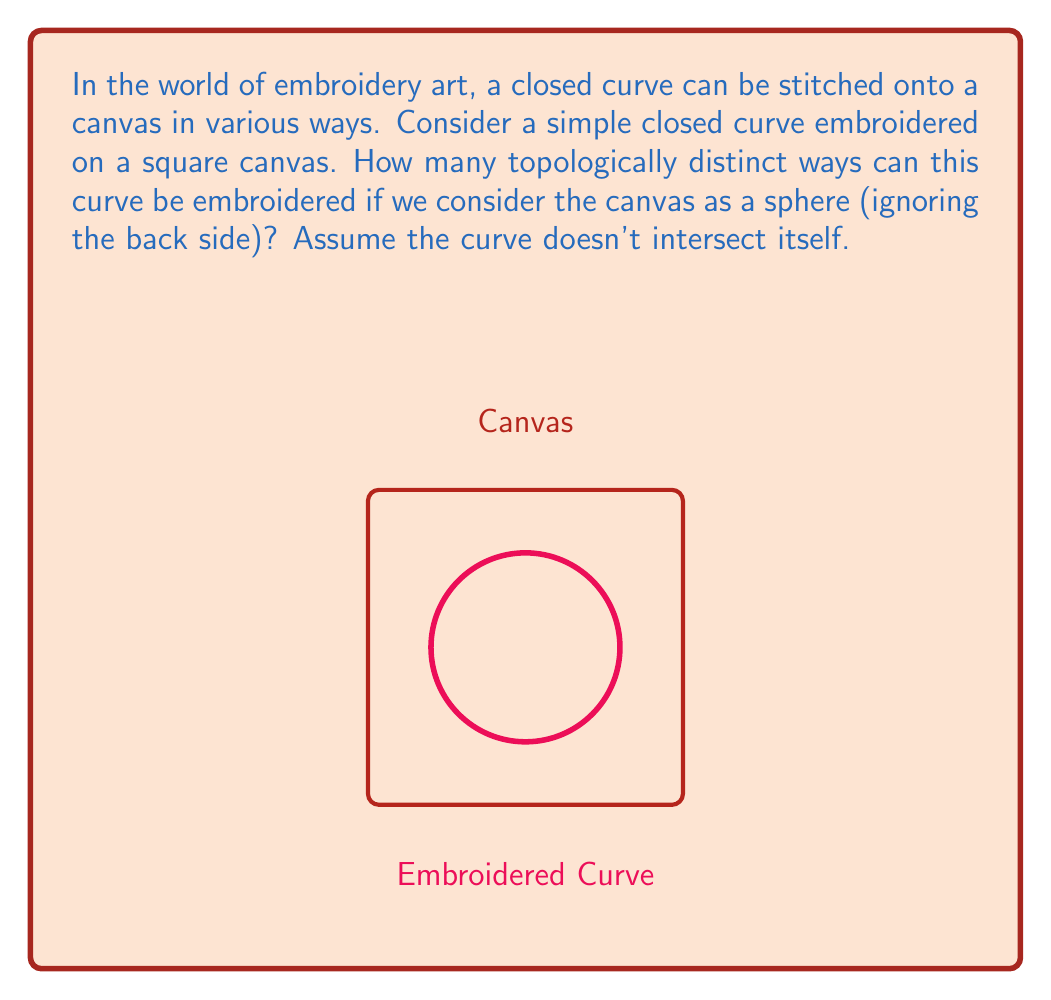Give your solution to this math problem. To approach this problem, we need to understand some key concepts in topology:

1. Topological equivalence: Two embeddings of a curve on a surface are topologically equivalent if one can be continuously deformed into the other without cutting or self-intersecting.

2. The square canvas as a sphere: Topologically, a sphere is equivalent to a plane with a point at infinity. When we consider the canvas as a sphere, we're essentially saying that all points on the edge of the square are identified as a single point.

3. Jordan Curve Theorem: A simple closed curve on a sphere divides the sphere into two regions.

Now, let's analyze the possible configurations:

1. The curve can be embedded in two fundamentally different ways:
   a. It can separate the sphere into two regions.
   b. It can be contractible to a point.

2. If the curve separates the sphere into two regions, these regions can be:
   a. Both non-empty (the curve is not close to the edge of the canvas).
   b. One empty and one non-empty (the curve encloses the point at infinity).

3. If the curve is contractible, it doesn't matter where on the canvas it's placed - all such curves are topologically equivalent.

Therefore, we have three topologically distinct ways to embroider the curve:
1. Separating the sphere into two non-empty regions.
2. Enclosing the point at infinity (equivalent to enclosing the edge of the square canvas).
3. Contractible to a point (a small loop anywhere on the canvas).

These three configurations are fundamentally different and cannot be continuously deformed into each other without cutting the curve or the surface.
Answer: 3 